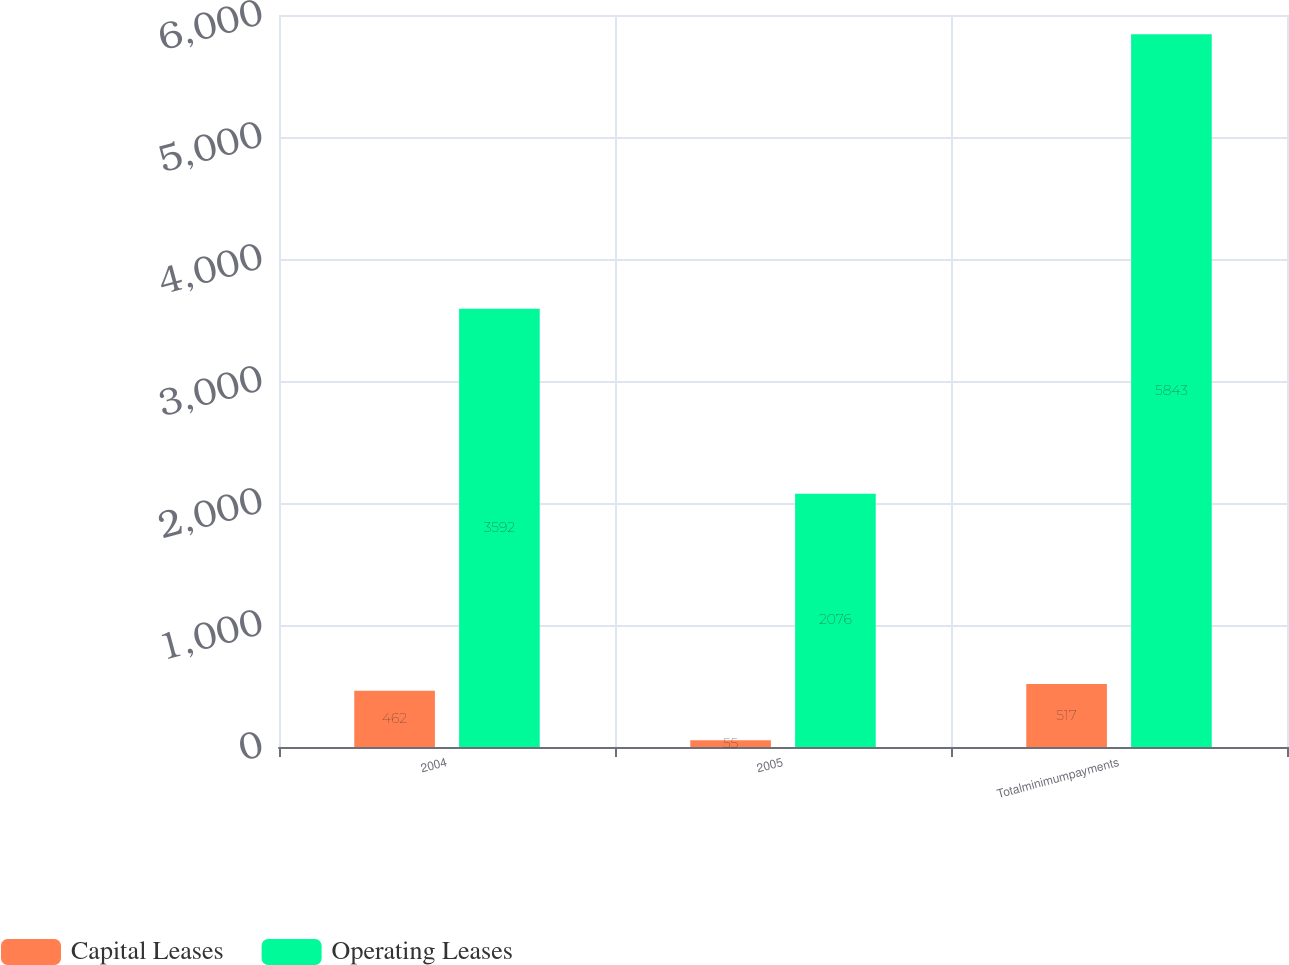Convert chart. <chart><loc_0><loc_0><loc_500><loc_500><stacked_bar_chart><ecel><fcel>2004<fcel>2005<fcel>Totalminimumpayments<nl><fcel>Capital Leases<fcel>462<fcel>55<fcel>517<nl><fcel>Operating Leases<fcel>3592<fcel>2076<fcel>5843<nl></chart> 